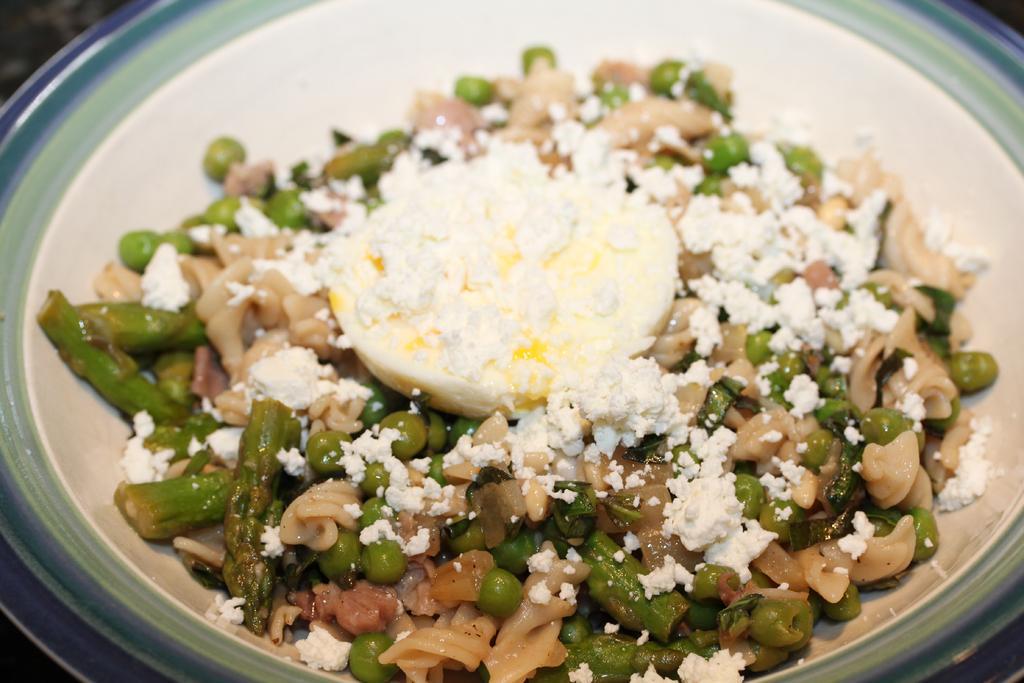Could you give a brief overview of what you see in this image? In this picture we can see the food is present in the plate. 